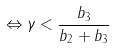Convert formula to latex. <formula><loc_0><loc_0><loc_500><loc_500>\Leftrightarrow \gamma < \frac { b _ { 3 } } { b _ { 2 } + b _ { 3 } }</formula> 